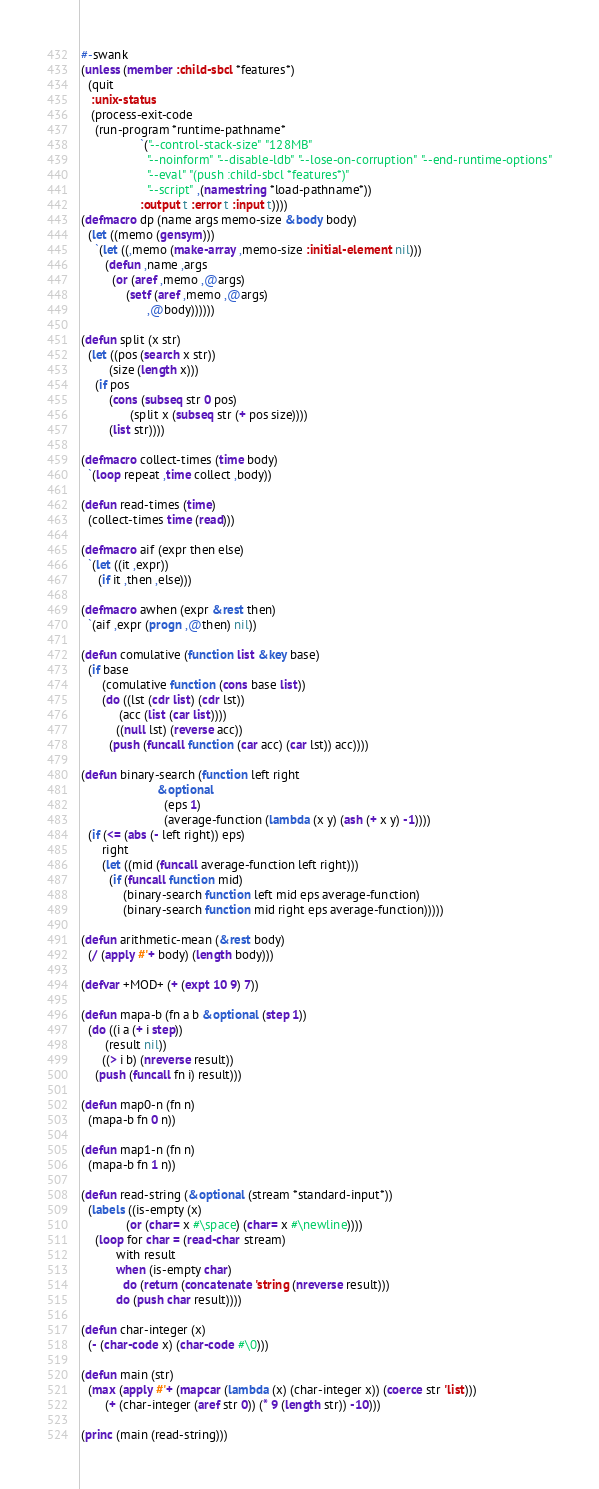Convert code to text. <code><loc_0><loc_0><loc_500><loc_500><_Lisp_>#-swank
(unless (member :child-sbcl *features*)
  (quit
   :unix-status
   (process-exit-code
    (run-program *runtime-pathname*
                 `("--control-stack-size" "128MB"
                   "--noinform" "--disable-ldb" "--lose-on-corruption" "--end-runtime-options"
                   "--eval" "(push :child-sbcl *features*)"
                   "--script" ,(namestring *load-pathname*))
                 :output t :error t :input t))))
(defmacro dp (name args memo-size &body body)
  (let ((memo (gensym)))
    `(let ((,memo (make-array ,memo-size :initial-element nil)))
       (defun ,name ,args
         (or (aref ,memo ,@args)
             (setf (aref ,memo ,@args)
                   ,@body))))))

(defun split (x str)
  (let ((pos (search x str))
        (size (length x)))
    (if pos
        (cons (subseq str 0 pos)
              (split x (subseq str (+ pos size))))
        (list str))))

(defmacro collect-times (time body)
  `(loop repeat ,time collect ,body))

(defun read-times (time)
  (collect-times time (read)))

(defmacro aif (expr then else)
  `(let ((it ,expr))
     (if it ,then ,else)))

(defmacro awhen (expr &rest then)
  `(aif ,expr (progn ,@then) nil))

(defun comulative (function list &key base)
  (if base
      (comulative function (cons base list))
      (do ((lst (cdr list) (cdr lst))
           (acc (list (car list))))
          ((null lst) (reverse acc))
        (push (funcall function (car acc) (car lst)) acc))))

(defun binary-search (function left right
                      &optional
                        (eps 1)
                        (average-function (lambda (x y) (ash (+ x y) -1))))
  (if (<= (abs (- left right)) eps)
      right
      (let ((mid (funcall average-function left right)))
        (if (funcall function mid)
            (binary-search function left mid eps average-function)
            (binary-search function mid right eps average-function)))))

(defun arithmetic-mean (&rest body)
  (/ (apply #'+ body) (length body)))

(defvar +MOD+ (+ (expt 10 9) 7))

(defun mapa-b (fn a b &optional (step 1))
  (do ((i a (+ i step))
       (result nil))
      ((> i b) (nreverse result))
    (push (funcall fn i) result)))

(defun map0-n (fn n)
  (mapa-b fn 0 n))

(defun map1-n (fn n)
  (mapa-b fn 1 n))

(defun read-string (&optional (stream *standard-input*))
  (labels ((is-empty (x)
             (or (char= x #\space) (char= x #\newline))))
    (loop for char = (read-char stream)
          with result
          when (is-empty char)
            do (return (concatenate 'string (nreverse result)))
          do (push char result))))

(defun char-integer (x)
  (- (char-code x) (char-code #\0)))

(defun main (str)
  (max (apply #'+ (mapcar (lambda (x) (char-integer x)) (coerce str 'list)))
       (+ (char-integer (aref str 0)) (* 9 (length str)) -10)))

(princ (main (read-string)))
</code> 